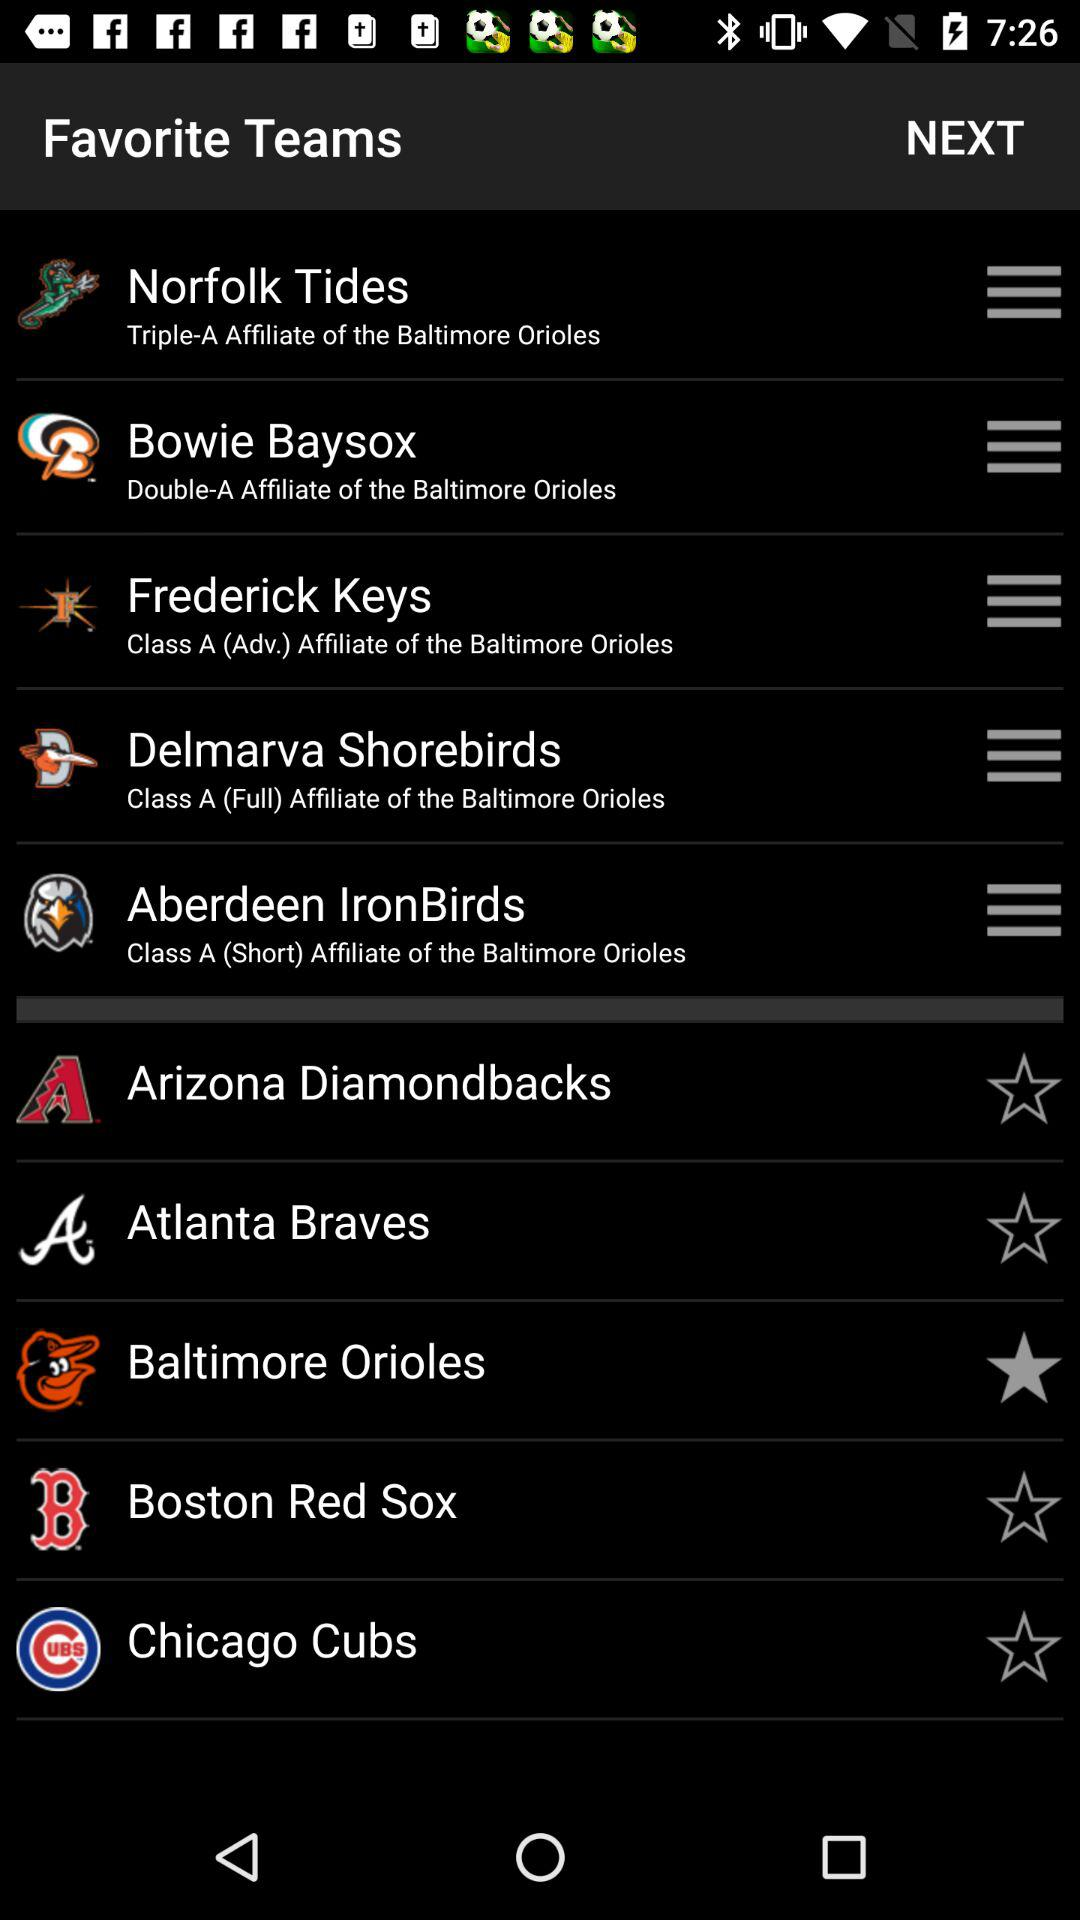Norfolk tides are affiliated with whom? The Norfolk Tides are affiliated with the "Triple-A Affiliate of the Baltimore Orioles". 